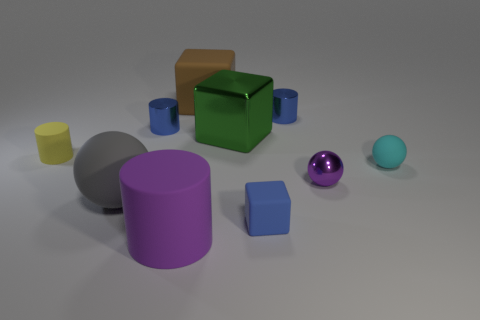Are there any small balls to the left of the tiny rubber object on the right side of the tiny rubber object that is in front of the cyan ball?
Make the answer very short. Yes. There is a purple thing to the left of the tiny shiny sphere; is it the same shape as the yellow matte object?
Your answer should be very brief. Yes. What shape is the tiny matte object that is in front of the shiny object in front of the tiny matte cylinder?
Give a very brief answer. Cube. There is a blue thing that is in front of the metal thing in front of the tiny thing right of the tiny purple metallic object; how big is it?
Offer a very short reply. Small. There is a metal object that is the same shape as the big gray matte thing; what color is it?
Your response must be concise. Purple. Do the yellow cylinder and the brown thing have the same size?
Provide a short and direct response. No. There is a block that is in front of the small cyan rubber object; what is it made of?
Ensure brevity in your answer.  Rubber. What number of other things are the same shape as the big green object?
Your answer should be very brief. 2. Is the shape of the yellow object the same as the large purple object?
Ensure brevity in your answer.  Yes. There is a small purple shiny object; are there any blue things in front of it?
Your answer should be compact. Yes. 